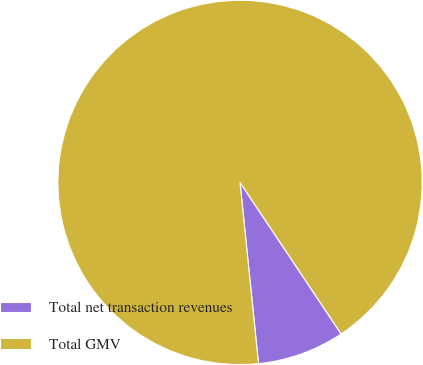Convert chart. <chart><loc_0><loc_0><loc_500><loc_500><pie_chart><fcel>Total net transaction revenues<fcel>Total GMV<nl><fcel>7.75%<fcel>92.25%<nl></chart> 